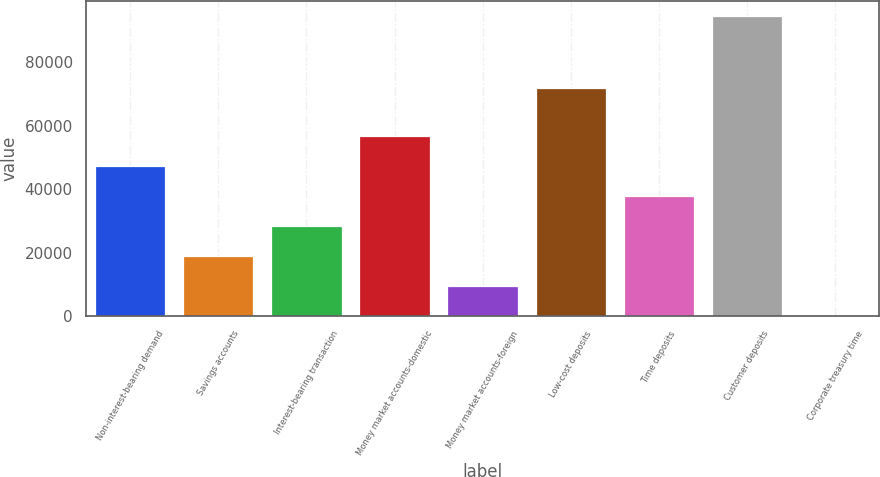Convert chart. <chart><loc_0><loc_0><loc_500><loc_500><bar_chart><fcel>Non-interest-bearing demand<fcel>Savings accounts<fcel>Interest-bearing transaction<fcel>Money market accounts-domestic<fcel>Money market accounts-foreign<fcel>Low-cost deposits<fcel>Time deposits<fcel>Customer deposits<fcel>Corporate treasury time<nl><fcel>47307<fcel>18933<fcel>28391<fcel>56765<fcel>9475<fcel>71813<fcel>37849<fcel>94597<fcel>17<nl></chart> 